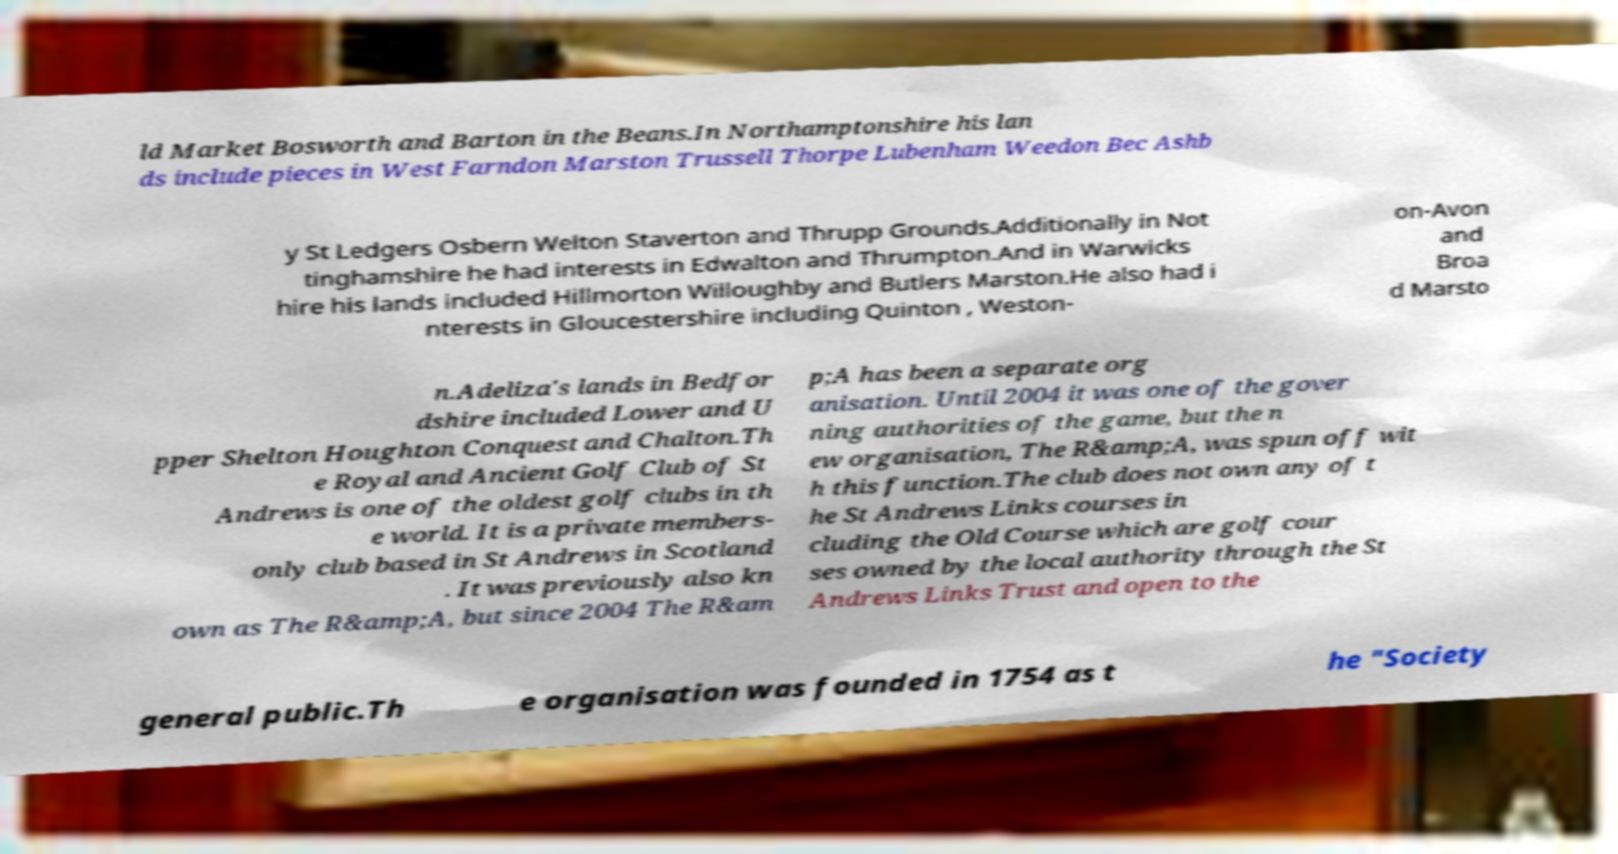Please identify and transcribe the text found in this image. ld Market Bosworth and Barton in the Beans.In Northamptonshire his lan ds include pieces in West Farndon Marston Trussell Thorpe Lubenham Weedon Bec Ashb y St Ledgers Osbern Welton Staverton and Thrupp Grounds.Additionally in Not tinghamshire he had interests in Edwalton and Thrumpton.And in Warwicks hire his lands included Hillmorton Willoughby and Butlers Marston.He also had i nterests in Gloucestershire including Quinton , Weston- on-Avon and Broa d Marsto n.Adeliza's lands in Bedfor dshire included Lower and U pper Shelton Houghton Conquest and Chalton.Th e Royal and Ancient Golf Club of St Andrews is one of the oldest golf clubs in th e world. It is a private members- only club based in St Andrews in Scotland . It was previously also kn own as The R&amp;A, but since 2004 The R&am p;A has been a separate org anisation. Until 2004 it was one of the gover ning authorities of the game, but the n ew organisation, The R&amp;A, was spun off wit h this function.The club does not own any of t he St Andrews Links courses in cluding the Old Course which are golf cour ses owned by the local authority through the St Andrews Links Trust and open to the general public.Th e organisation was founded in 1754 as t he "Society 